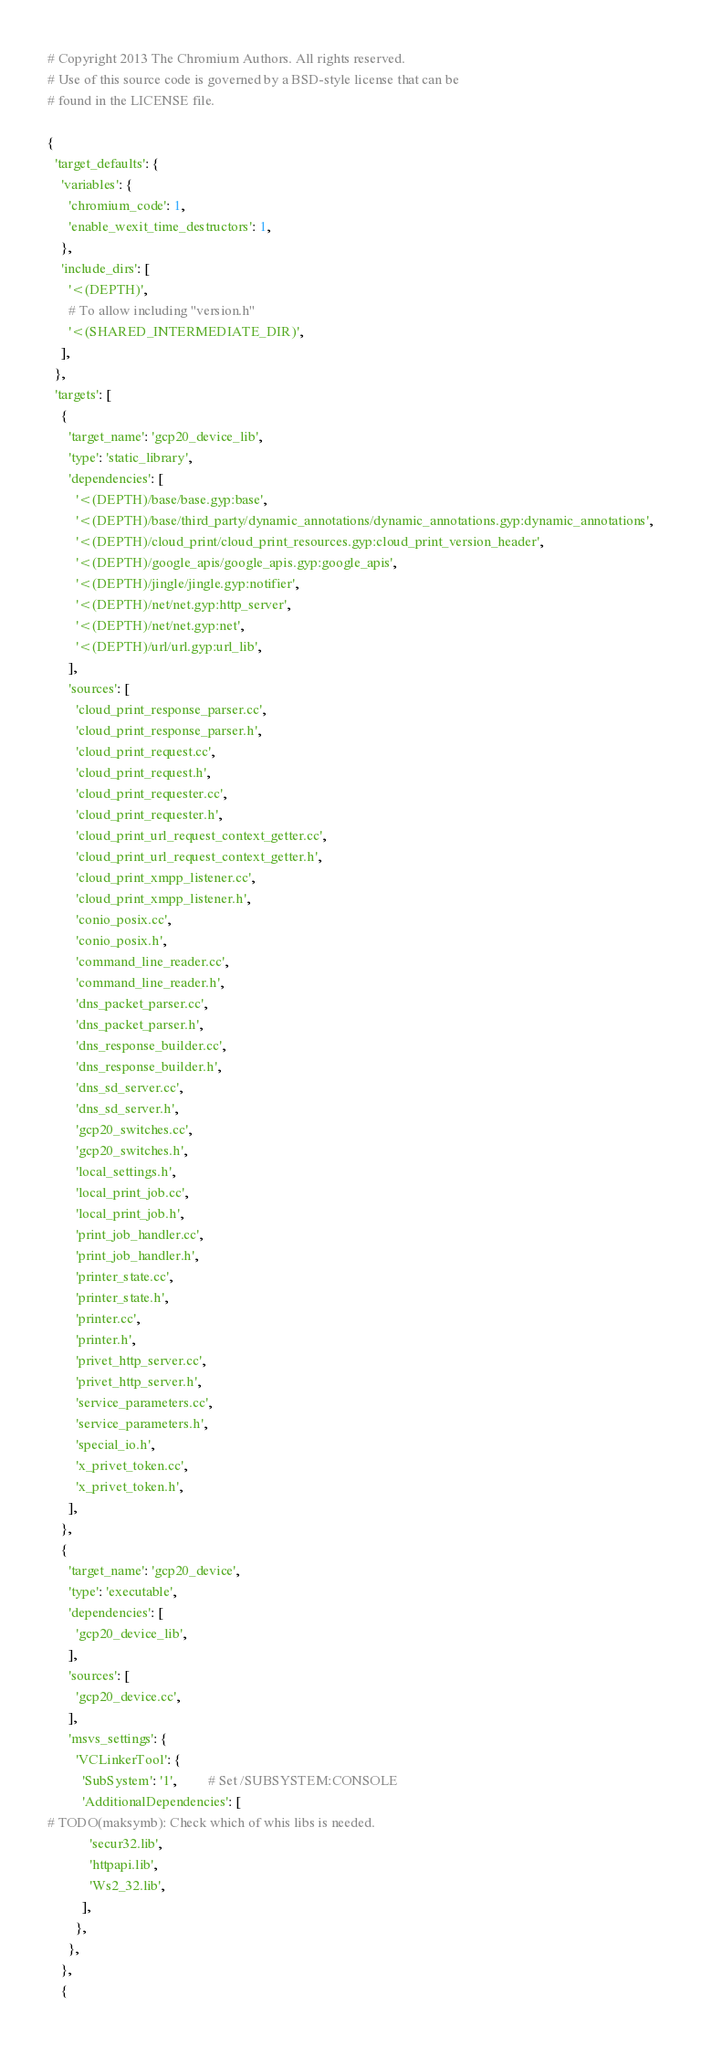Convert code to text. <code><loc_0><loc_0><loc_500><loc_500><_Python_># Copyright 2013 The Chromium Authors. All rights reserved.
# Use of this source code is governed by a BSD-style license that can be
# found in the LICENSE file.

{
  'target_defaults': {
    'variables': {
      'chromium_code': 1,
      'enable_wexit_time_destructors': 1,
    },
    'include_dirs': [
      '<(DEPTH)',
      # To allow including "version.h"
      '<(SHARED_INTERMEDIATE_DIR)',
    ],
  },
  'targets': [
    {
      'target_name': 'gcp20_device_lib',
      'type': 'static_library',
      'dependencies': [
        '<(DEPTH)/base/base.gyp:base',
        '<(DEPTH)/base/third_party/dynamic_annotations/dynamic_annotations.gyp:dynamic_annotations',
        '<(DEPTH)/cloud_print/cloud_print_resources.gyp:cloud_print_version_header',
        '<(DEPTH)/google_apis/google_apis.gyp:google_apis',
        '<(DEPTH)/jingle/jingle.gyp:notifier',
        '<(DEPTH)/net/net.gyp:http_server',
        '<(DEPTH)/net/net.gyp:net',
        '<(DEPTH)/url/url.gyp:url_lib',
      ],
      'sources': [
        'cloud_print_response_parser.cc',
        'cloud_print_response_parser.h',
        'cloud_print_request.cc',
        'cloud_print_request.h',
        'cloud_print_requester.cc',
        'cloud_print_requester.h',
        'cloud_print_url_request_context_getter.cc',
        'cloud_print_url_request_context_getter.h',
        'cloud_print_xmpp_listener.cc',
        'cloud_print_xmpp_listener.h',
        'conio_posix.cc',
        'conio_posix.h',
        'command_line_reader.cc',
        'command_line_reader.h',
        'dns_packet_parser.cc',
        'dns_packet_parser.h',
        'dns_response_builder.cc',
        'dns_response_builder.h',
        'dns_sd_server.cc',
        'dns_sd_server.h',
        'gcp20_switches.cc',
        'gcp20_switches.h',
        'local_settings.h',
        'local_print_job.cc',
        'local_print_job.h',
        'print_job_handler.cc',
        'print_job_handler.h',
        'printer_state.cc',
        'printer_state.h',
        'printer.cc',
        'printer.h',
        'privet_http_server.cc',
        'privet_http_server.h',
        'service_parameters.cc',
        'service_parameters.h',
        'special_io.h',
        'x_privet_token.cc',
        'x_privet_token.h',
      ],
    },
    {
      'target_name': 'gcp20_device',
      'type': 'executable',
      'dependencies': [
        'gcp20_device_lib',
      ],
      'sources': [
        'gcp20_device.cc',
      ],
      'msvs_settings': {
        'VCLinkerTool': {
          'SubSystem': '1',         # Set /SUBSYSTEM:CONSOLE
          'AdditionalDependencies': [
# TODO(maksymb): Check which of whis libs is needed.
            'secur32.lib',
            'httpapi.lib',
            'Ws2_32.lib',
          ],
        },
      },
    },
    {</code> 